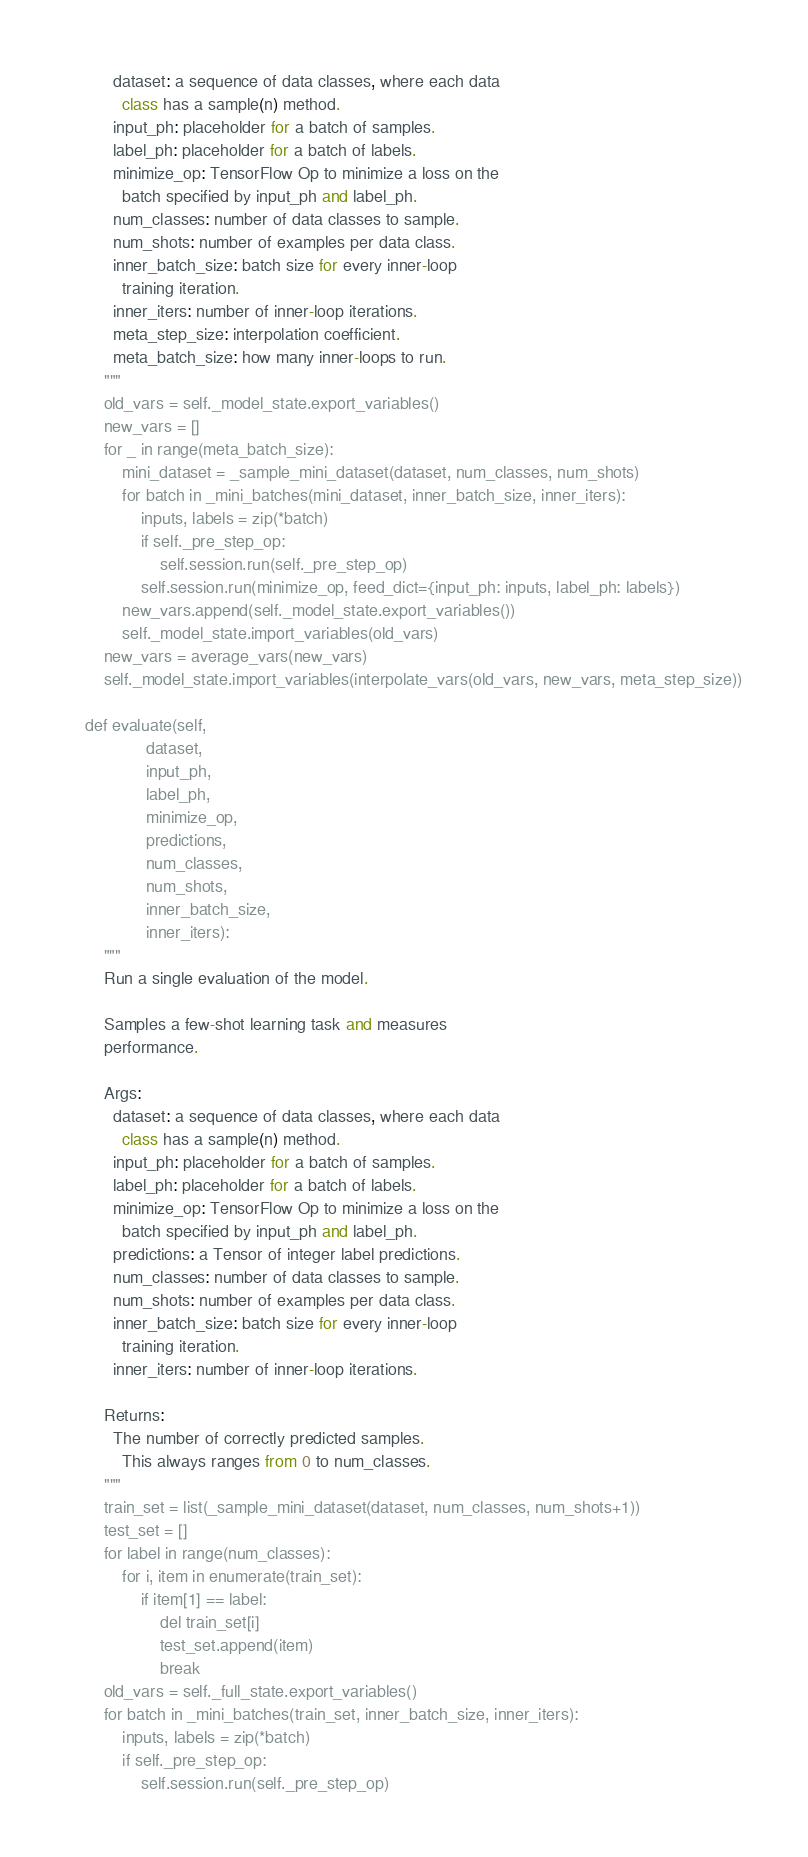<code> <loc_0><loc_0><loc_500><loc_500><_Python_>          dataset: a sequence of data classes, where each data
            class has a sample(n) method.
          input_ph: placeholder for a batch of samples.
          label_ph: placeholder for a batch of labels.
          minimize_op: TensorFlow Op to minimize a loss on the
            batch specified by input_ph and label_ph.
          num_classes: number of data classes to sample.
          num_shots: number of examples per data class.
          inner_batch_size: batch size for every inner-loop
            training iteration.
          inner_iters: number of inner-loop iterations.
          meta_step_size: interpolation coefficient.
          meta_batch_size: how many inner-loops to run.
        """
        old_vars = self._model_state.export_variables()
        new_vars = []
        for _ in range(meta_batch_size):
            mini_dataset = _sample_mini_dataset(dataset, num_classes, num_shots)
            for batch in _mini_batches(mini_dataset, inner_batch_size, inner_iters):
                inputs, labels = zip(*batch)
                if self._pre_step_op:
                    self.session.run(self._pre_step_op)
                self.session.run(minimize_op, feed_dict={input_ph: inputs, label_ph: labels})
            new_vars.append(self._model_state.export_variables())
            self._model_state.import_variables(old_vars)
        new_vars = average_vars(new_vars)
        self._model_state.import_variables(interpolate_vars(old_vars, new_vars, meta_step_size))

    def evaluate(self,
                 dataset,
                 input_ph,
                 label_ph,
                 minimize_op,
                 predictions,
                 num_classes,
                 num_shots,
                 inner_batch_size,
                 inner_iters):
        """
        Run a single evaluation of the model.

        Samples a few-shot learning task and measures
        performance.

        Args:
          dataset: a sequence of data classes, where each data
            class has a sample(n) method.
          input_ph: placeholder for a batch of samples.
          label_ph: placeholder for a batch of labels.
          minimize_op: TensorFlow Op to minimize a loss on the
            batch specified by input_ph and label_ph.
          predictions: a Tensor of integer label predictions.
          num_classes: number of data classes to sample.
          num_shots: number of examples per data class.
          inner_batch_size: batch size for every inner-loop
            training iteration.
          inner_iters: number of inner-loop iterations.

        Returns:
          The number of correctly predicted samples.
            This always ranges from 0 to num_classes.
        """
        train_set = list(_sample_mini_dataset(dataset, num_classes, num_shots+1))
        test_set = []
        for label in range(num_classes):
            for i, item in enumerate(train_set):
                if item[1] == label:
                    del train_set[i]
                    test_set.append(item)
                    break
        old_vars = self._full_state.export_variables()
        for batch in _mini_batches(train_set, inner_batch_size, inner_iters):
            inputs, labels = zip(*batch)
            if self._pre_step_op:
                self.session.run(self._pre_step_op)</code> 